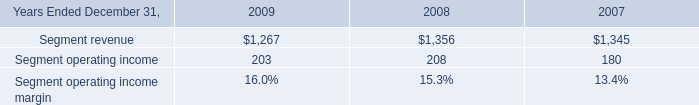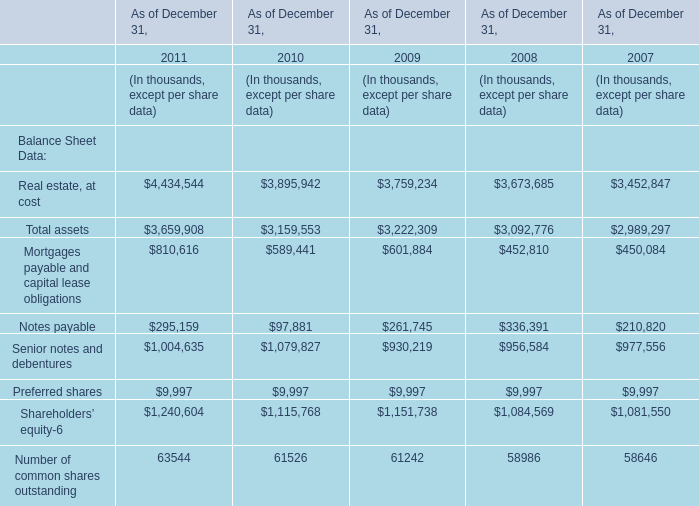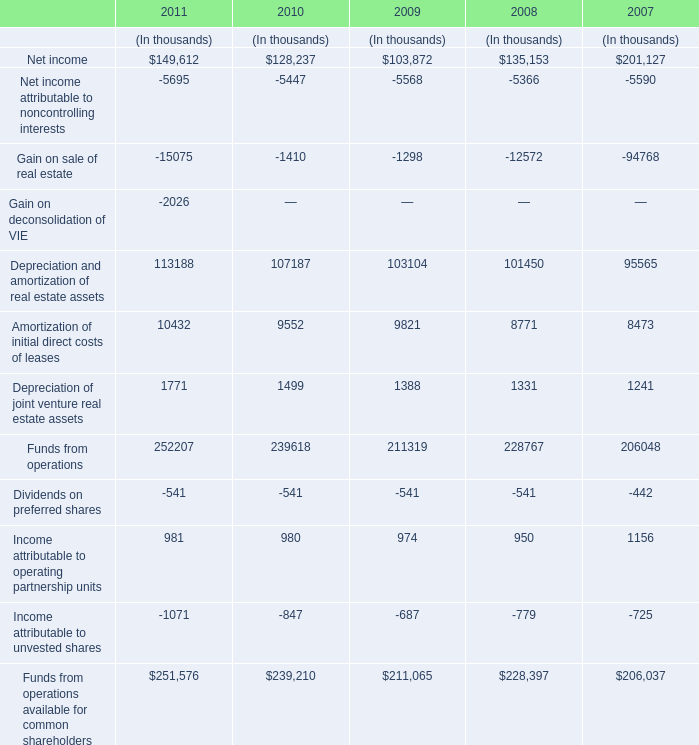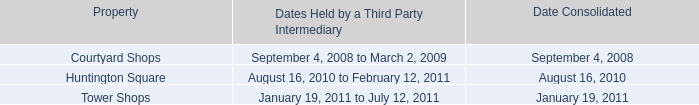what was the percent of the change in the consulting segment revenue from 2008 2009\\n 
Computations: ((1267 - 1356) / 1356)
Answer: -0.06563. 